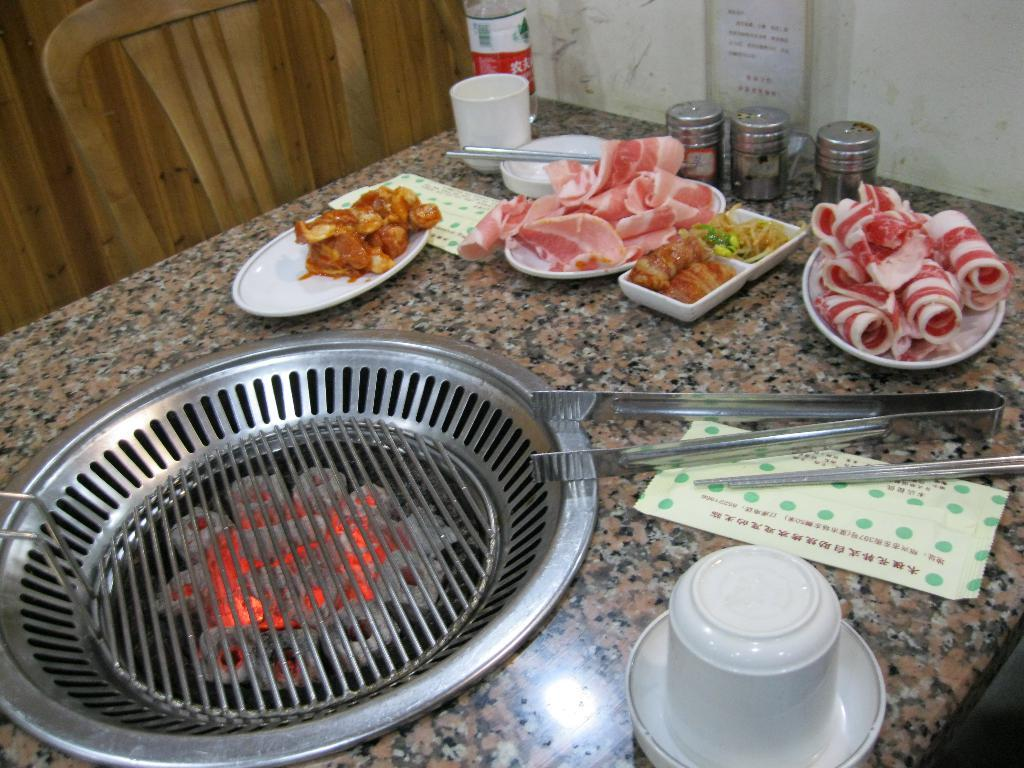What can be seen on the plates in the image? There are food items on the plates in the image. What type of container is present in the image besides plates? There is a bottle, bowls, and jars in the image. What is the purpose of the tong in the image? The tong in the image is likely used for serving or handling food items. What is the source of heat in the image? There is a burner flame in the image, which could be used for cooking or heating. What type of seating is visible in the image? There is a chair in the image. What can be seen in the background of the image? There is a wall visible in the background of the image. How does the cub interact with the food items in the image? There is no cub present in the image; it only features plates with food items, a bottle, bowls, jars, a cup, cards, a tong, a burner flame, a chair, and a wall in the background. What act is being performed by the people in the image? There are no people present in the image, so it is impossible to determine what act they might be performing. How does the earthquake affect the food items in the image? There is no earthquake present in the image, and the food items are stationary on the plates. 